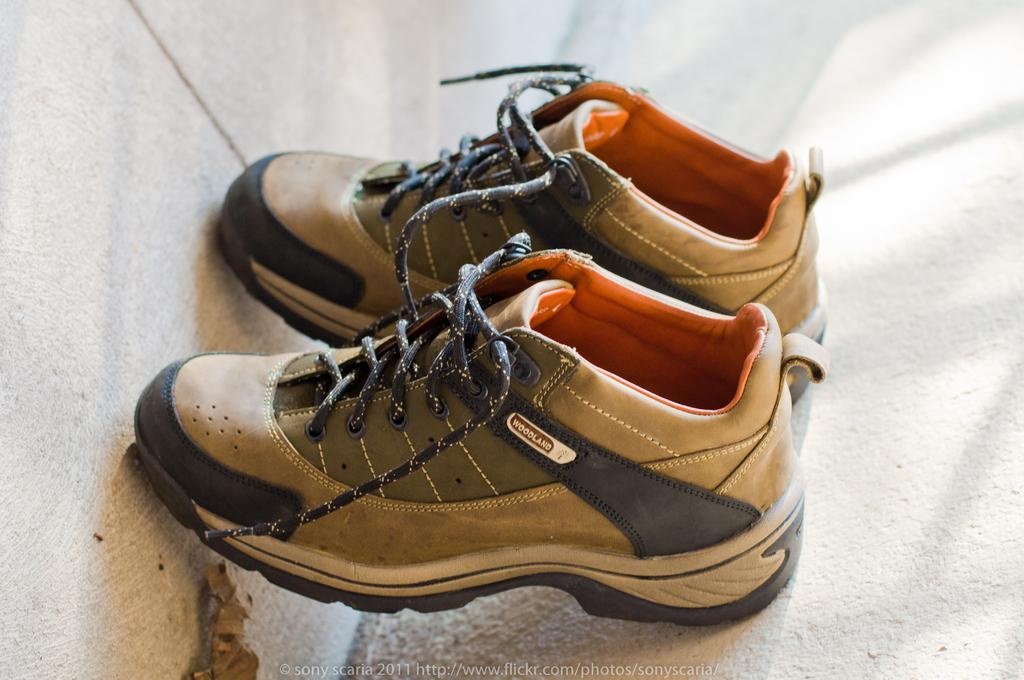What type of shoes are in the image? There is a pair of woodland shoes in the image. Where are the shoes located? The shoes are on a surface in the image. What can be seen in the background of the image? There is a wall visible in the image. What additional object is present in the image? A dried leaf is present in the image. What information is provided at the bottom of the image? There is text at the bottom of the image. What type of game is being played on the table in the image? There is no table or game present in the image; it only features a pair of woodland shoes, a surface, a wall, a dried leaf, and text at the bottom. 